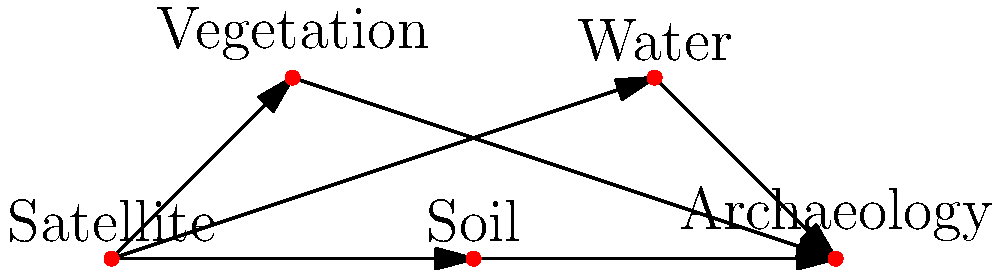Based on the network diagram, which element serves as the primary data source for identifying potential archaeological sites using satellite imagery and vegetation patterns? To answer this question, let's analyze the network diagram step-by-step:

1. The diagram shows five nodes: Satellite, Vegetation, Soil, Water, and Archaeology.

2. We can see that the "Satellite" node has outgoing arrows to three other nodes: Vegetation, Soil, and Water.

3. These three nodes (Vegetation, Soil, and Water) all have outgoing arrows to the "Archaeology" node.

4. This structure indicates that the Satellite node is the primary source of information, which is then used to analyze Vegetation, Soil, and Water patterns.

5. The information from Vegetation, Soil, and Water analysis is then used to identify potential archaeological sites.

6. Among the given options in the question, we are asked about satellite imagery and vegetation patterns.

7. In the diagram, we can see that the Satellite node directly connects to the Vegetation node, which then connects to the Archaeology node.

Therefore, the primary data source for identifying potential archaeological sites using satellite imagery and vegetation patterns is the Satellite node.
Answer: Satellite 